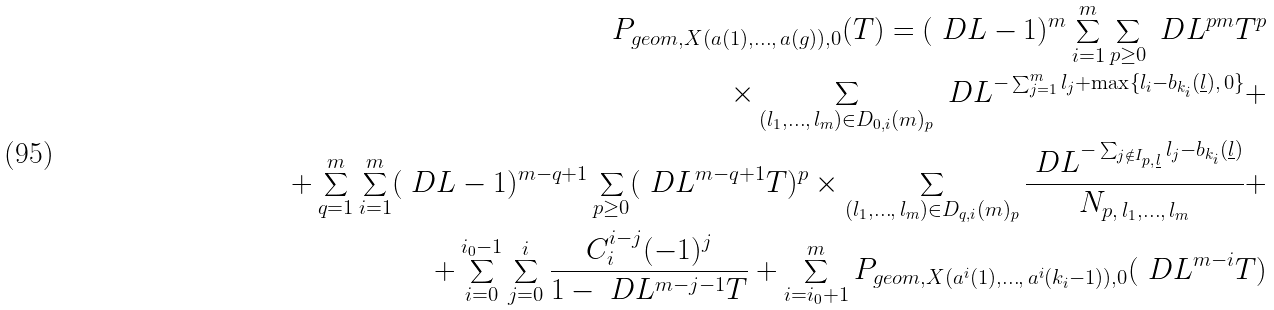<formula> <loc_0><loc_0><loc_500><loc_500>P _ { g e o m , X ( a ( 1 ) , \dots , \, a ( g ) ) , 0 } ( T ) = ( \ D L - 1 ) ^ { m } \sum _ { i = 1 } ^ { m } \sum _ { p \geq 0 } \ D L ^ { p m } T ^ { p } \\ \times \sum _ { ( l _ { 1 } , \dots , \, l _ { m } ) \in D _ { 0 , i } ( m ) _ { p } } \ D L ^ { - \sum _ { j = 1 } ^ { m } l _ { j } + \max \{ l _ { i } - b _ { k _ { i } } ( \underline { l } ) , \, 0 \} } + \\ + \sum _ { q = 1 } ^ { m } \sum _ { i = 1 } ^ { m } ( \ D L - 1 ) ^ { m - q + 1 } \sum _ { p \geq 0 } ( \ D L ^ { m - q + 1 } T ) ^ { p } \times \sum _ { ( l _ { 1 } , \dots , \, l _ { m } ) \in D _ { q , i } ( m ) _ { p } } \frac { \ D L ^ { - \sum _ { j \notin I _ { p , \, \underline { l } } } l _ { j } - b _ { k _ { i } } ( \underline { l } ) } } { N _ { p , \, l _ { 1 } , \dots , \, l _ { m } } } + \\ + \sum _ { i = 0 } ^ { i _ { 0 } - 1 } \sum _ { j = 0 } ^ { i } \frac { C _ { i } ^ { i - j } ( - 1 ) ^ { j } } { 1 - \ D L ^ { m - j - 1 } T } + \sum _ { i = i _ { 0 } + 1 } ^ { m } P _ { g e o m , X ( a ^ { i } ( 1 ) , \dots , \, a ^ { i } ( k _ { i } - 1 ) ) , 0 } ( \ D L ^ { m - i } T )</formula> 